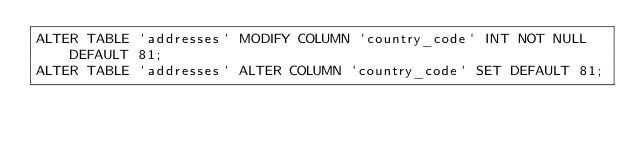Convert code to text. <code><loc_0><loc_0><loc_500><loc_500><_SQL_>ALTER TABLE `addresses` MODIFY COLUMN `country_code` INT NOT NULL  DEFAULT 81;
ALTER TABLE `addresses` ALTER COLUMN `country_code` SET DEFAULT 81;
</code> 